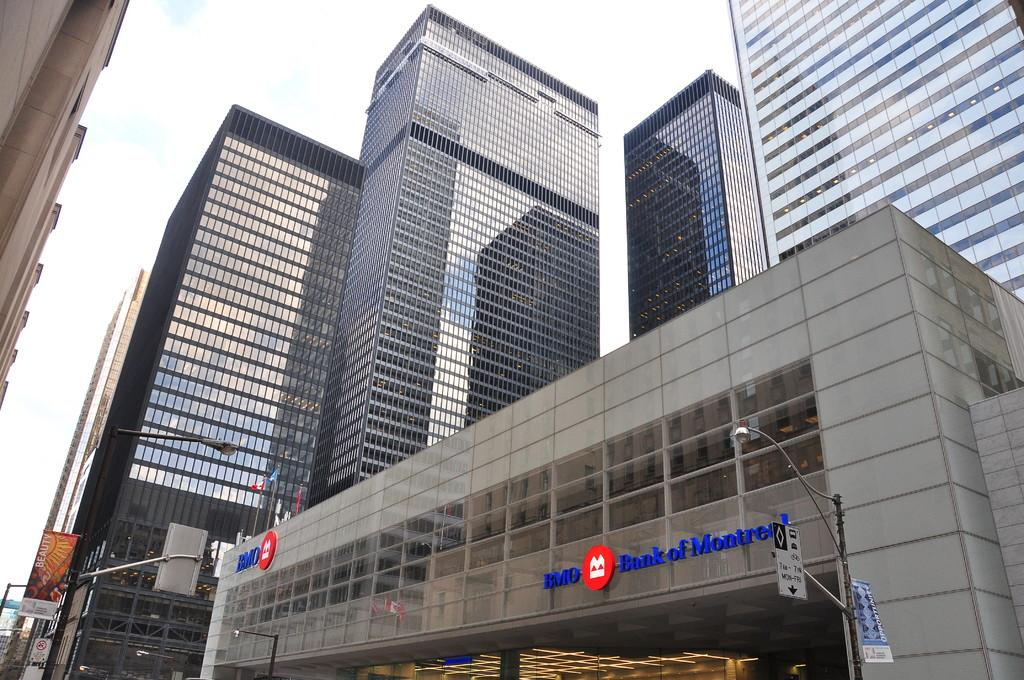<image>
Summarize the visual content of the image. Taller buildings flank the wider but shorter Bank of Montreal 